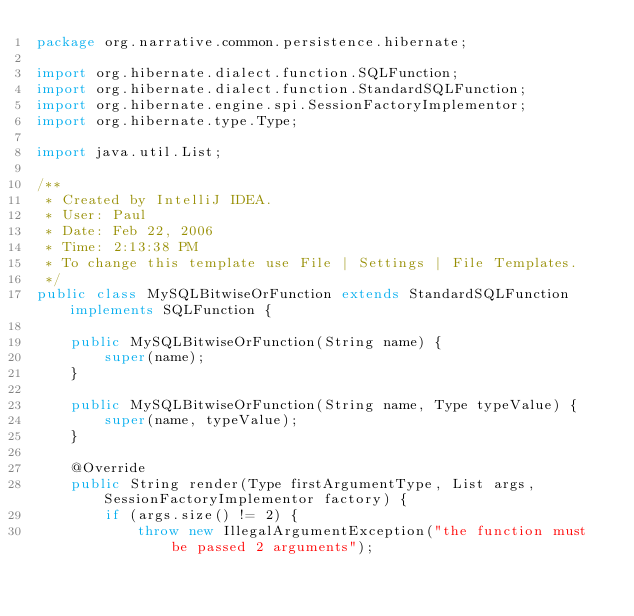Convert code to text. <code><loc_0><loc_0><loc_500><loc_500><_Java_>package org.narrative.common.persistence.hibernate;

import org.hibernate.dialect.function.SQLFunction;
import org.hibernate.dialect.function.StandardSQLFunction;
import org.hibernate.engine.spi.SessionFactoryImplementor;
import org.hibernate.type.Type;

import java.util.List;

/**
 * Created by IntelliJ IDEA.
 * User: Paul
 * Date: Feb 22, 2006
 * Time: 2:13:38 PM
 * To change this template use File | Settings | File Templates.
 */
public class MySQLBitwiseOrFunction extends StandardSQLFunction implements SQLFunction {

    public MySQLBitwiseOrFunction(String name) {
        super(name);
    }

    public MySQLBitwiseOrFunction(String name, Type typeValue) {
        super(name, typeValue);
    }

    @Override
    public String render(Type firstArgumentType, List args, SessionFactoryImplementor factory) {
        if (args.size() != 2) {
            throw new IllegalArgumentException("the function must be passed 2 arguments");</code> 